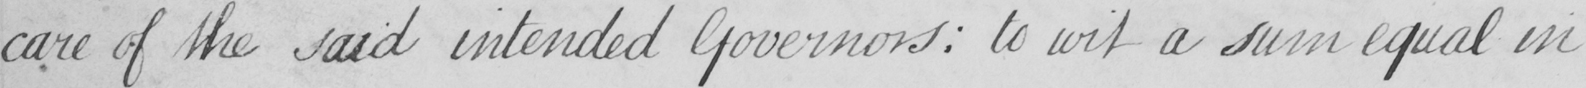What text is written in this handwritten line? care of the said intended Governors :  to wit a sum equal in 